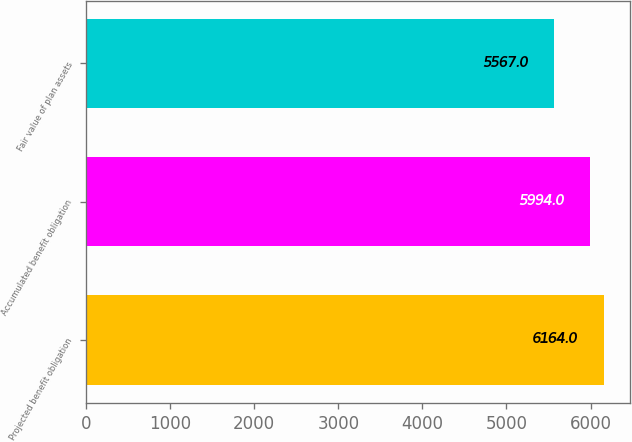Convert chart to OTSL. <chart><loc_0><loc_0><loc_500><loc_500><bar_chart><fcel>Projected benefit obligation<fcel>Accumulated benefit obligation<fcel>Fair value of plan assets<nl><fcel>6164<fcel>5994<fcel>5567<nl></chart> 